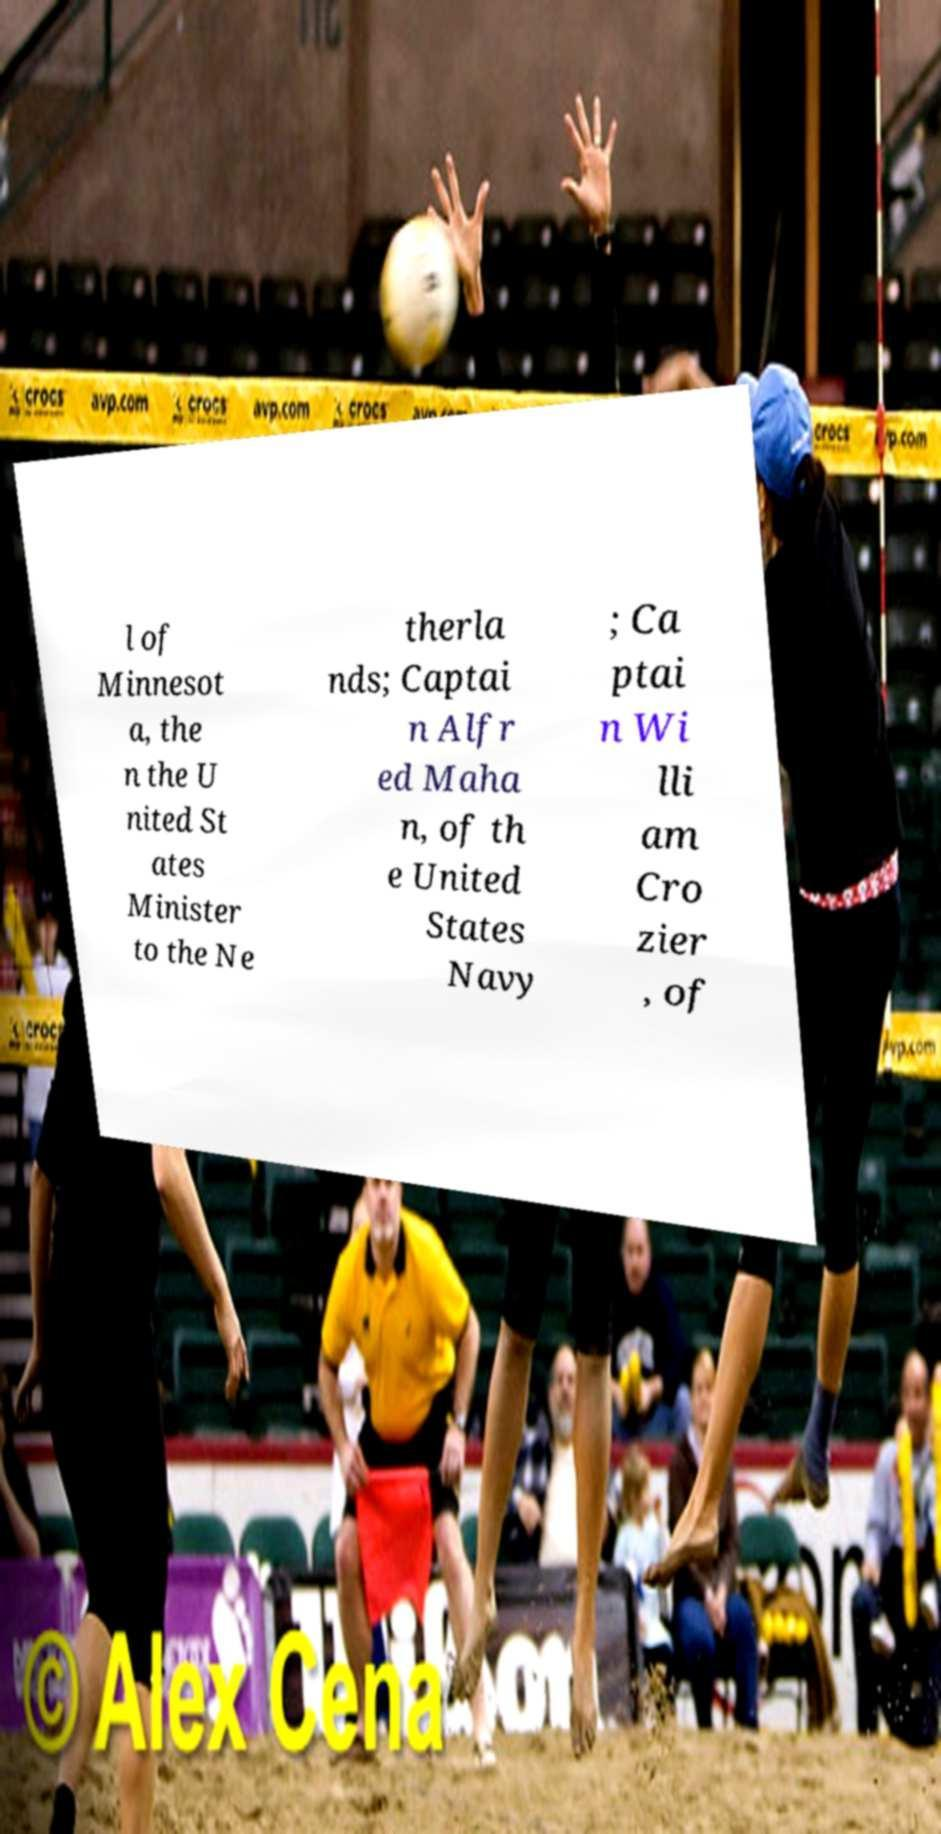Please read and relay the text visible in this image. What does it say? l of Minnesot a, the n the U nited St ates Minister to the Ne therla nds; Captai n Alfr ed Maha n, of th e United States Navy ; Ca ptai n Wi lli am Cro zier , of 